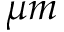<formula> <loc_0><loc_0><loc_500><loc_500>\mu m</formula> 